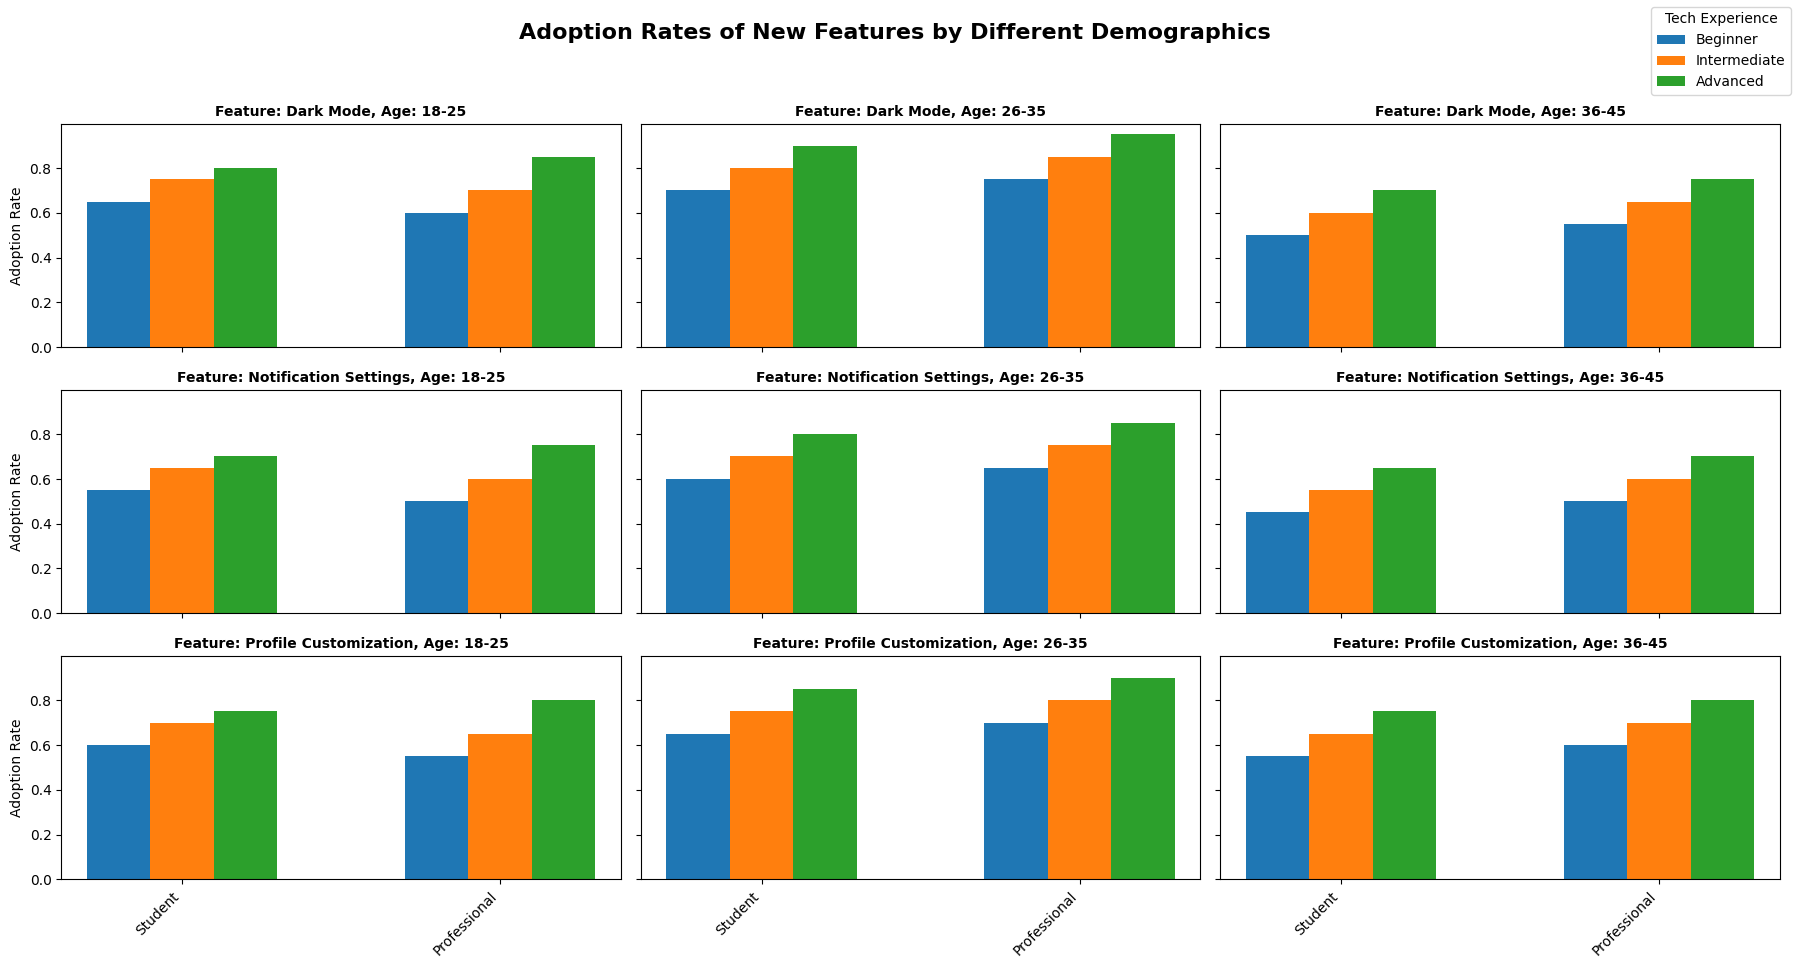Which age group and tech experience level have the highest adoption rate for Dark Mode? Look for the highest bar representing Dark Mode adoption rates across different age groups and tech experience levels. The highest adoption rate is found for 26-35 age group, Advanced tech experience level.
Answer: 26-35, Advanced Does the average adoption rate for Notification Settings increase with age for professionals? Calculate the average adoption rate for professionals within each age group for Notification Settings. Compare these averages to see if they increase: 
18-25: (0.50 + 0.60 + 0.75) / 3 = 0.6167
26-35: (0.65 + 0.75 + 0.85) / 3 = 0.75
36-45: (0.50 + 0.60 + 0.70) / 3 = 0.60. The average does not consistently increase with age.
Answer: No Which has a higher adoption rate for Profile Customization among 18-25 beginners: Students or Professionals? Look at the bars representing beginners (blue) in the 18-25 age group for Profile Customization, and compare the heights for Students and Professionals. Students have a higher adoption rate of 0.60 compared to professionals with 0.55.
Answer: Students Which feature has the lowest adoption rate among Advanced professionals in the 36-45 age group? Find the bars representing Advanced professionals (green) for all features in the 36-45 age group and identify the shortest bar, which represents the lowest adoption rate. Notification Settings has the lowest rate for this group at 0.70.
Answer: Notification Settings Is the adoption rate of Dark Mode for beginner students in the 26-35 age group higher than that of intermediate professionals in the 18-25 age group? Compare the heights of the corresponding bars for Dark Mode: beginners (blue) 26-35 students (0.70) and intermediate (orange) 18-25 professionals (0.70). Both are equal.
Answer: No, they are equal Compare the adoption rates of Notification Settings and Profile Customization for beginner professionals in the 36-45 age group. Which is higher? Look at the corresponding bars for Notification Settings and Profile Customization for beginner professionals in the 36-45 age group. For Notification Settings, the rate is 0.50, and for Profile Customization, it is 0.60. Profile Customization has a higher rate.
Answer: Profile Customization What's the average adoption rate for Dark Mode across all tech experience levels for 18-25 professionals? Calculate the average adoption rate for each tech experience level within the 18-25 age group:
(0.60 + 0.70 + 0.85) / 3 = (2.15 / 3) = 0.7167.
Answer: 0.7167 